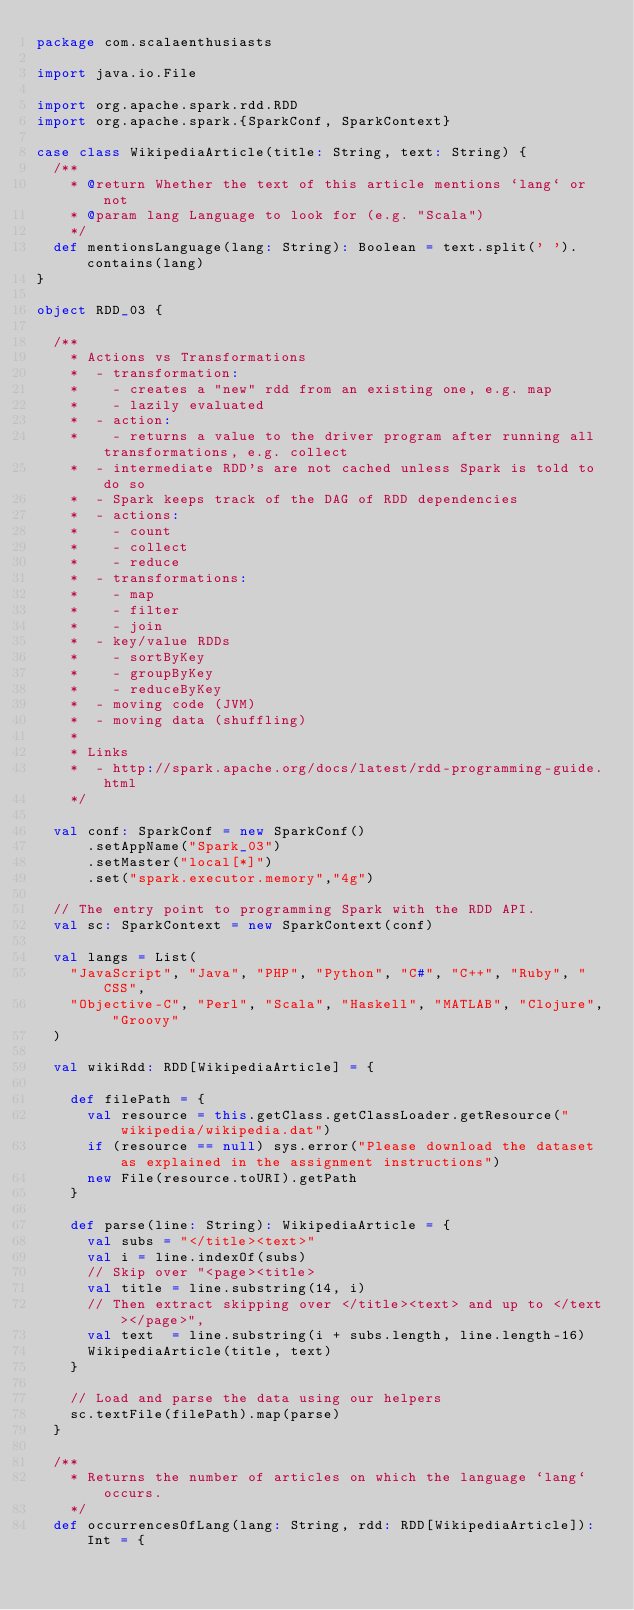<code> <loc_0><loc_0><loc_500><loc_500><_Scala_>package com.scalaenthusiasts

import java.io.File

import org.apache.spark.rdd.RDD
import org.apache.spark.{SparkConf, SparkContext}

case class WikipediaArticle(title: String, text: String) {
  /**
    * @return Whether the text of this article mentions `lang` or not
    * @param lang Language to look for (e.g. "Scala")
    */
  def mentionsLanguage(lang: String): Boolean = text.split(' ').contains(lang)
}

object RDD_03 {

  /**
    * Actions vs Transformations
    *  - transformation:
    *    - creates a "new" rdd from an existing one, e.g. map
    *    - lazily evaluated
    *  - action:
    *    - returns a value to the driver program after running all transformations, e.g. collect
    *  - intermediate RDD's are not cached unless Spark is told to do so
    *  - Spark keeps track of the DAG of RDD dependencies
    *  - actions:
    *    - count
    *    - collect
    *    - reduce
    *  - transformations:
    *    - map
    *    - filter
    *    - join
    *  - key/value RDDs
    *    - sortByKey
    *    - groupByKey
    *    - reduceByKey
    *  - moving code (JVM)
    *  - moving data (shuffling)
    *
    * Links
    *  - http://spark.apache.org/docs/latest/rdd-programming-guide.html
    */

  val conf: SparkConf = new SparkConf()
      .setAppName("Spark_03")
      .setMaster("local[*]")
      .set("spark.executor.memory","4g")

  // The entry point to programming Spark with the RDD API.
  val sc: SparkContext = new SparkContext(conf)

  val langs = List(
    "JavaScript", "Java", "PHP", "Python", "C#", "C++", "Ruby", "CSS",
    "Objective-C", "Perl", "Scala", "Haskell", "MATLAB", "Clojure", "Groovy"
  )

  val wikiRdd: RDD[WikipediaArticle] = {

    def filePath = {
      val resource = this.getClass.getClassLoader.getResource("wikipedia/wikipedia.dat")
      if (resource == null) sys.error("Please download the dataset as explained in the assignment instructions")
      new File(resource.toURI).getPath
    }

    def parse(line: String): WikipediaArticle = {
      val subs = "</title><text>"
      val i = line.indexOf(subs)
      // Skip over "<page><title>
      val title = line.substring(14, i)
      // Then extract skipping over </title><text> and up to </text></page>",
      val text  = line.substring(i + subs.length, line.length-16)
      WikipediaArticle(title, text)
    }

    // Load and parse the data using our helpers
    sc.textFile(filePath).map(parse)
  }

  /**
    * Returns the number of articles on which the language `lang` occurs.
    */
  def occurrencesOfLang(lang: String, rdd: RDD[WikipediaArticle]): Int = {</code> 